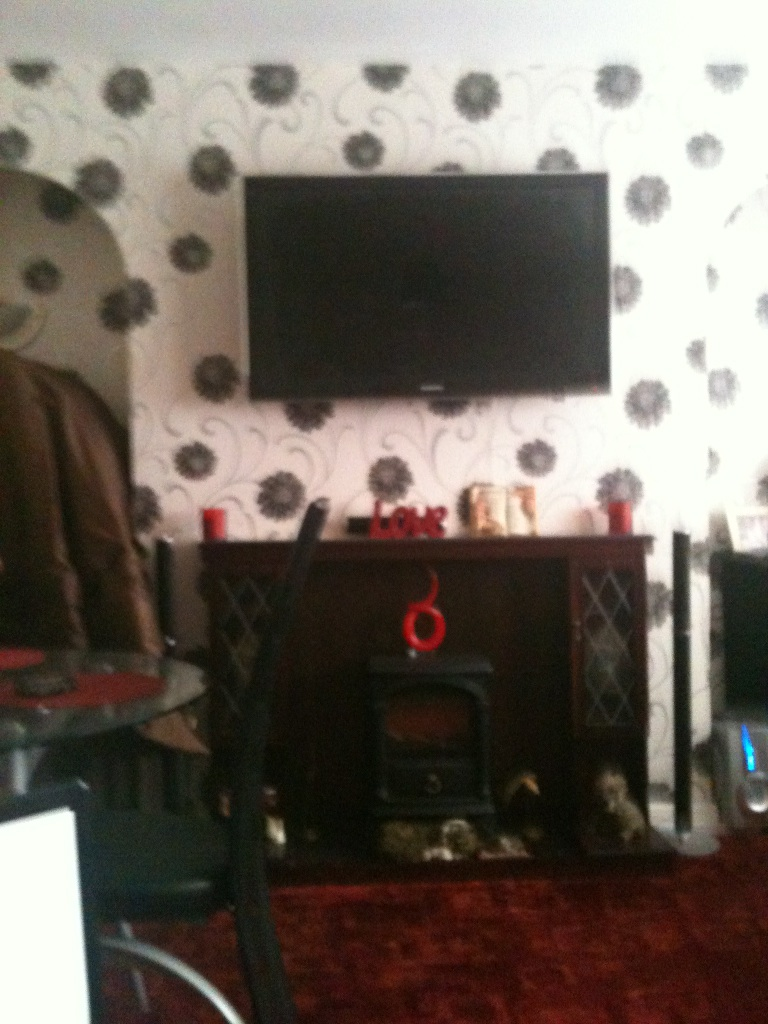What is this item? This is a television mounted on the wall. It is part of a cozy living room setup that also features a fireplace below it, enhancing the room's warm and inviting ambiance. 